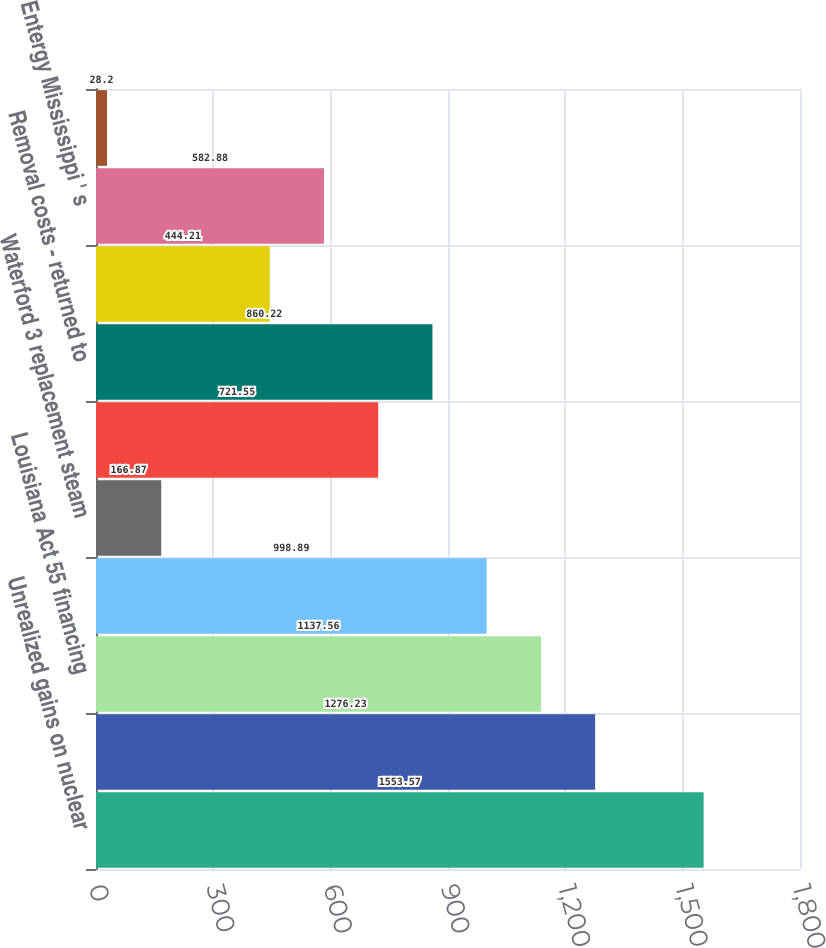<chart> <loc_0><loc_0><loc_500><loc_500><bar_chart><fcel>Unrealized gains on nuclear<fcel>Vidalia purchased power<fcel>Louisiana Act 55 financing<fcel>Business combination<fcel>Waterford 3 replacement steam<fcel>Grand Gulf sale-leaseback -<fcel>Removal costs - returned to<fcel>Entergy Arkansas ' s<fcel>Entergy Mississippi ' s<fcel>Asset retirement obligation -<nl><fcel>1553.57<fcel>1276.23<fcel>1137.56<fcel>998.89<fcel>166.87<fcel>721.55<fcel>860.22<fcel>444.21<fcel>582.88<fcel>28.2<nl></chart> 